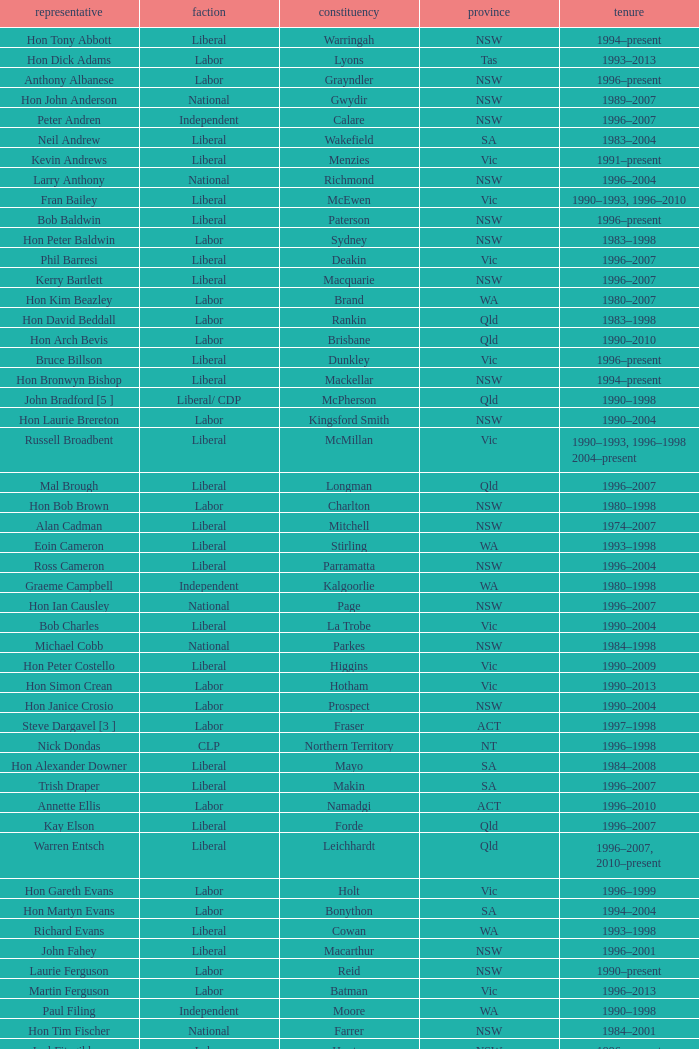What state did Hon David Beddall belong to? Qld. 